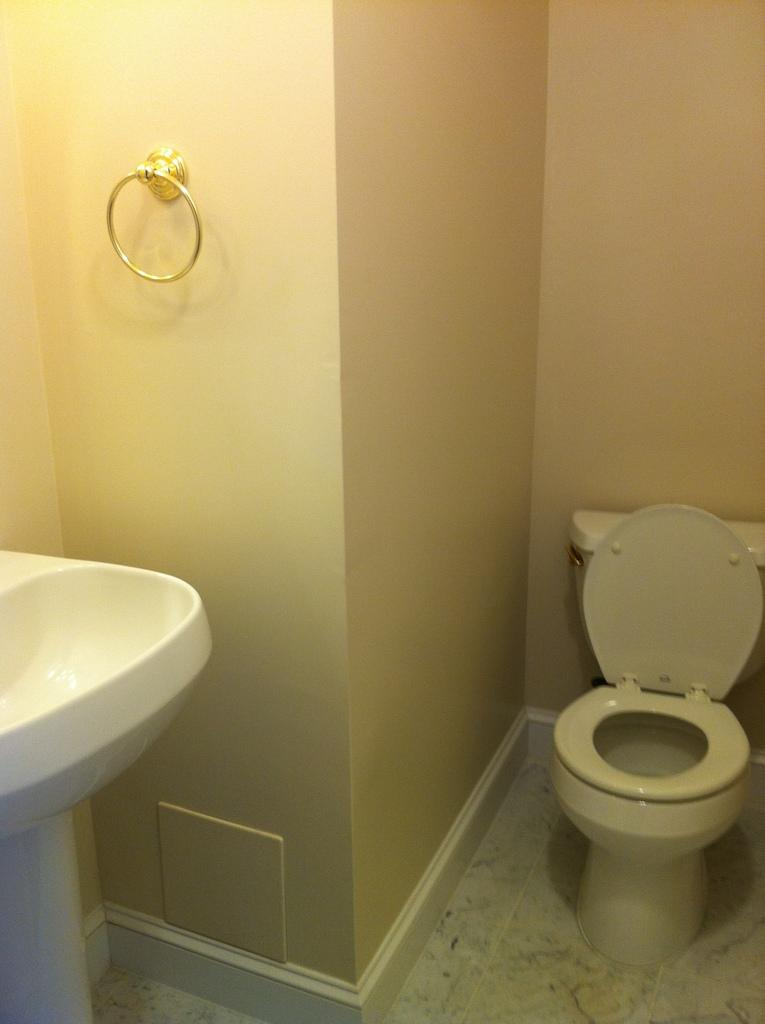Where was the image taken? The image is taken in a washroom. What can be seen on the left side of the image? There is a wash basin on the left side of the image. What is located on the right side of the image? There is a toilet on the right side of the image. What is the purpose of the handle on the left side of the image? The handle is likely for controlling the water flow in the wash basin. What type of poison is being used to flavor the water in the image? There is no poison or flavoring present in the image; it is a washroom with a wash basin and a toilet. 